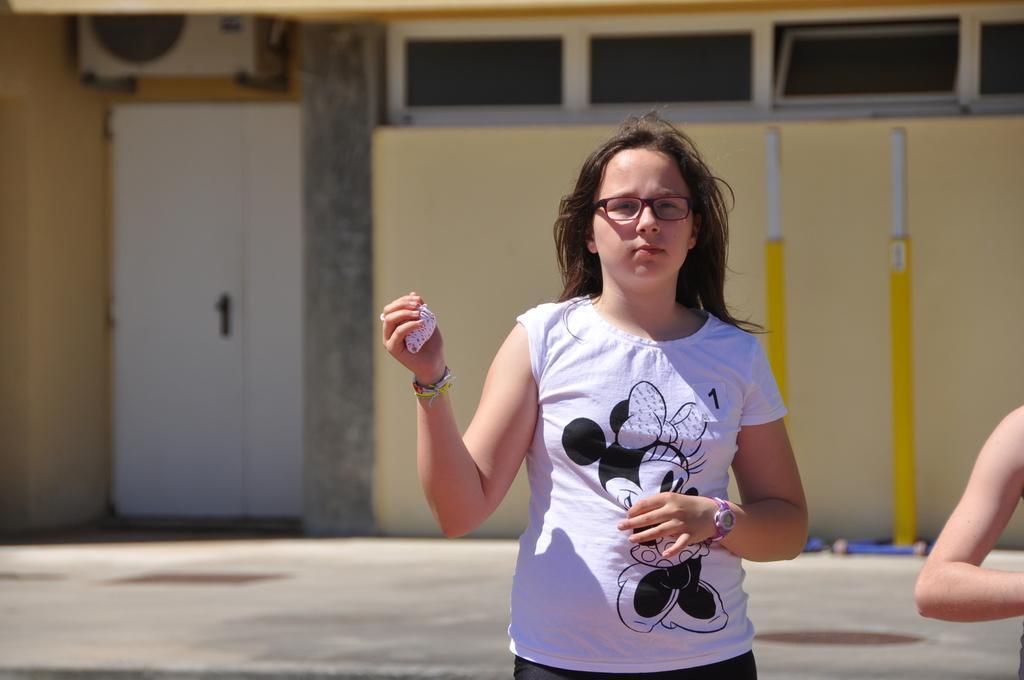In one or two sentences, can you explain what this image depicts? In this image in the center there is one woman and beside her there is another person, in the background there is a house, wall, windows and air conditioner. At the bottom there is a walkway. 